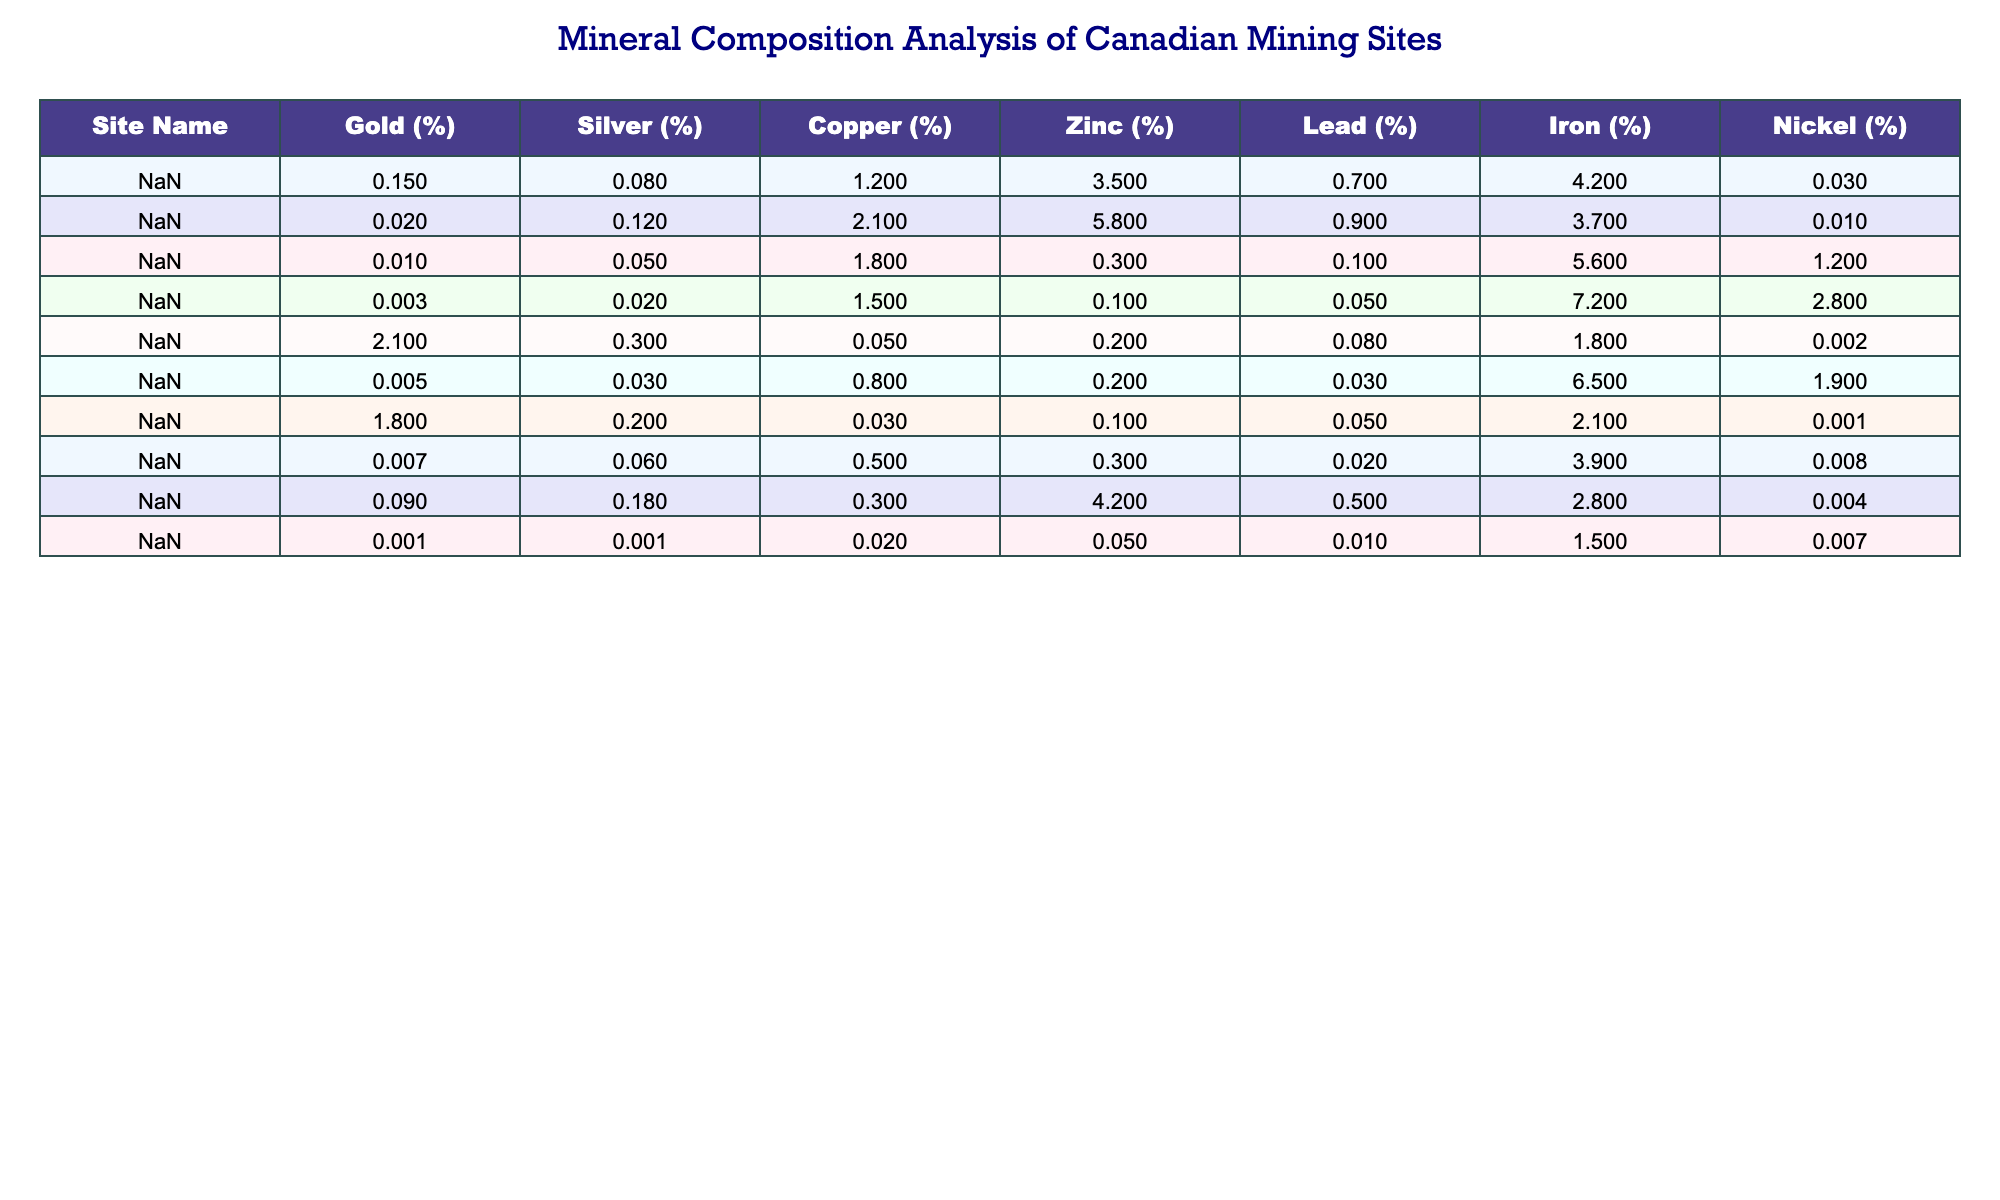What is the highest percentage of Gold found in the table? The highest percentage of Gold is 2.1%, which can be seen in the Red Lake Mine row of the table.
Answer: 2.1% Which site has the highest concentration of Copper? The highest concentration of Copper is 2.1%, which is located at the Kidd Creek Mine.
Answer: 2.1% What is the average percentage of Zinc across all mining sites? To find the average percentage of Zinc, add up all the Zinc values (3.5 + 5.8 + 0.3 + 0.1 + 0.2 + 0.2 + 0.1 + 4.2 + 0.05) which equals 14.45, then divide by the number of sites (9) giving 14.45/9 = 1.6%.
Answer: 1.6% Is there any site that has more than 0.5% Lead? The sites with Lead percentages greater than 0.5% are Strathcona Mine (0.7%), Kidd Creek Mine (0.9%), and LaRonde Mine (0.5%). Therefore, there are sites that exceed 0.5%.
Answer: Yes Which site shows the highest Iron content, and what is that percentage? The highest Iron content is at Voisey's Bay with 7.2%. This row contains the highest Iron percentage in the table.
Answer: 7.2% What is the difference in Silver content between the Strathcona Mine and the Raglan Mine? For Silver, Strathcona Mine has 0.08% and Raglan Mine has 0.03%. The difference is calculated by subtracting Raglan's percentage from Strathcona's: 0.08 - 0.03 = 0.05%.
Answer: 0.05% Calculate the total percentage of Nickel from the five sites with the lowest Nickel content. The five sites with the lowest Nickel content are Kid Creek Mine (0.01%), Sudbury Basin (1.2%), Red Lake Mine (0.002%), Hemlo Gold Mine (0.001%), and Highland Valley Copper (0.008%). Adding these together gives 0.01 + 1.2 + 0.002 + 0.001 + 0.008 = 1.221%.
Answer: 1.221% Is there any site where all mineral percentages (Gold, Silver, Copper, Zinc, Lead, Iron, Nickel) exceed 1%? No site in the table has all mineral percentages exceeding 1%. Red Lake Mine has Gold at 2.1%, but other minerals are below 1%. Thus, the fact is false.
Answer: No Which site(s) show both high Gold and low Nickel concentrations? Analyzing the sites, Hemlo Gold Mine has Gold at 1.8% and Nickel at 0.001%, indicating it has a high Gold concentration and low Nickel concentration.
Answer: Hemlo Gold Mine How many sites have Iron content greater than 5%? From the table, only two sites show Iron content greater than 5%, which are Sudbury Basin (5.6%) and Voisey's Bay (7.2%). Thus, the answer is 2.
Answer: 2 